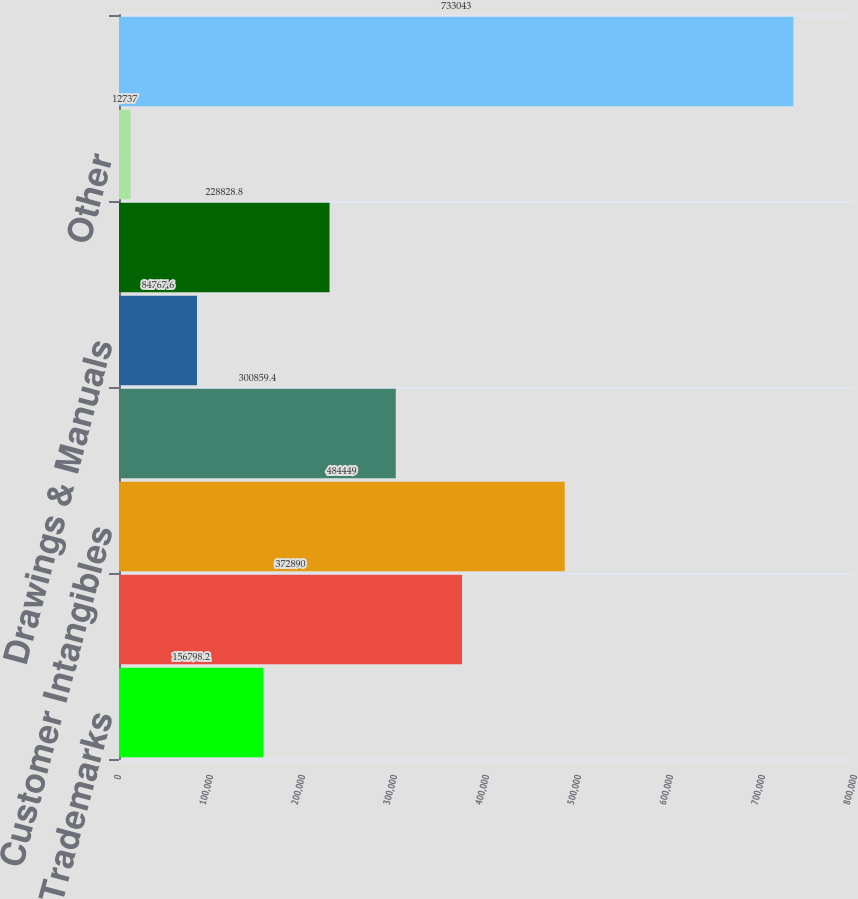Convert chart to OTSL. <chart><loc_0><loc_0><loc_500><loc_500><bar_chart><fcel>Trademarks<fcel>Patents<fcel>Customer Intangibles<fcel>Unpatented Technologies<fcel>Drawings & Manuals<fcel>Distributor Relationships<fcel>Other<fcel>Total<nl><fcel>156798<fcel>372890<fcel>484449<fcel>300859<fcel>84767.6<fcel>228829<fcel>12737<fcel>733043<nl></chart> 